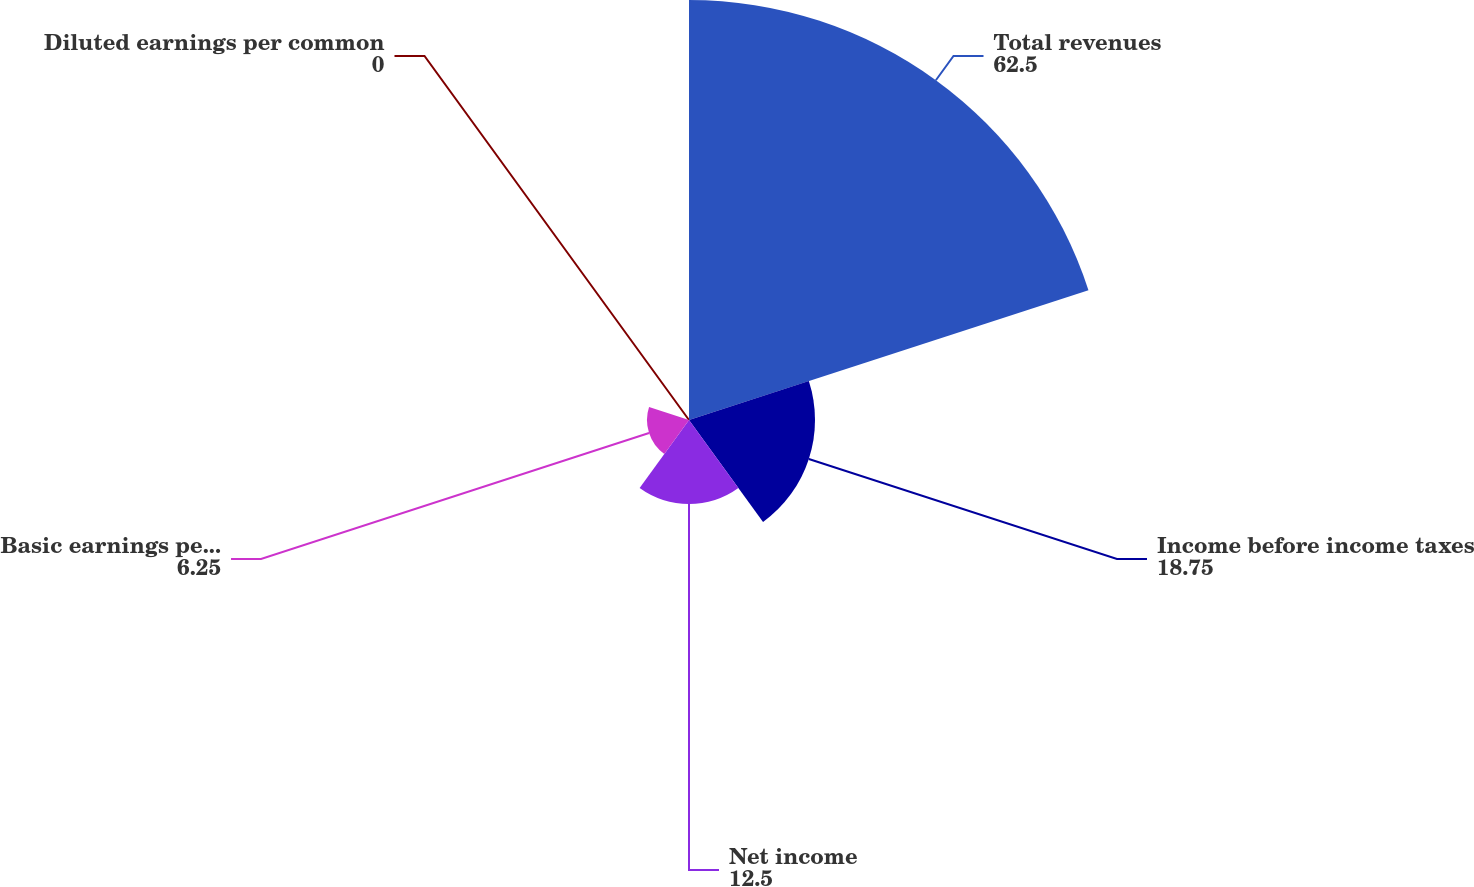Convert chart. <chart><loc_0><loc_0><loc_500><loc_500><pie_chart><fcel>Total revenues<fcel>Income before income taxes<fcel>Net income<fcel>Basic earnings per common<fcel>Diluted earnings per common<nl><fcel>62.5%<fcel>18.75%<fcel>12.5%<fcel>6.25%<fcel>0.0%<nl></chart> 